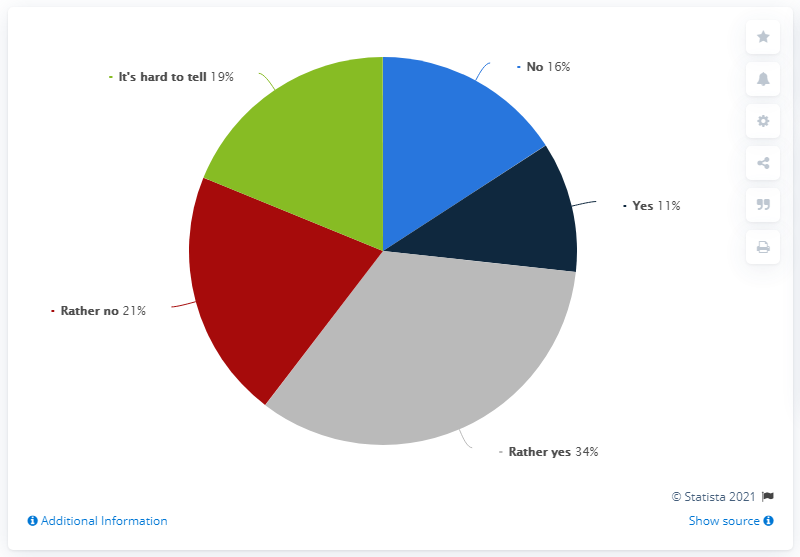Give some essential details in this illustration. What is the most popular response? I prefer to answer with a definitive yes. The sum of positive feedbacks is 45. 